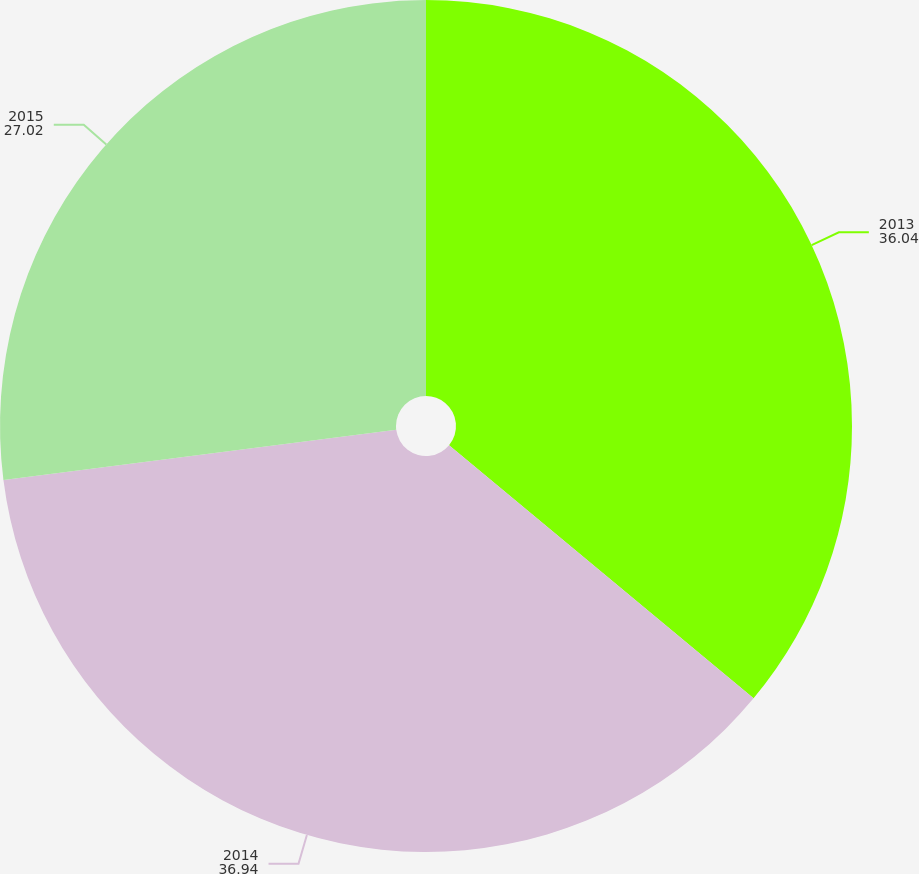<chart> <loc_0><loc_0><loc_500><loc_500><pie_chart><fcel>2013<fcel>2014<fcel>2015<nl><fcel>36.04%<fcel>36.94%<fcel>27.02%<nl></chart> 